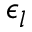Convert formula to latex. <formula><loc_0><loc_0><loc_500><loc_500>\epsilon _ { l }</formula> 